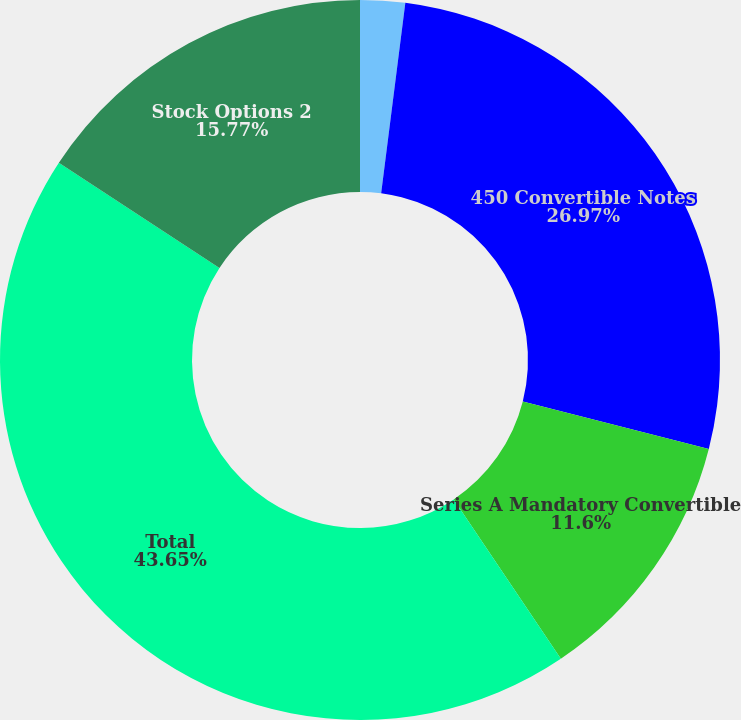Convert chart to OTSL. <chart><loc_0><loc_0><loc_500><loc_500><pie_chart><fcel>Stock Options and Non-vested<fcel>450 Convertible Notes<fcel>Series A Mandatory Convertible<fcel>Total<fcel>Stock Options 2<nl><fcel>2.01%<fcel>26.97%<fcel>11.6%<fcel>43.65%<fcel>15.77%<nl></chart> 